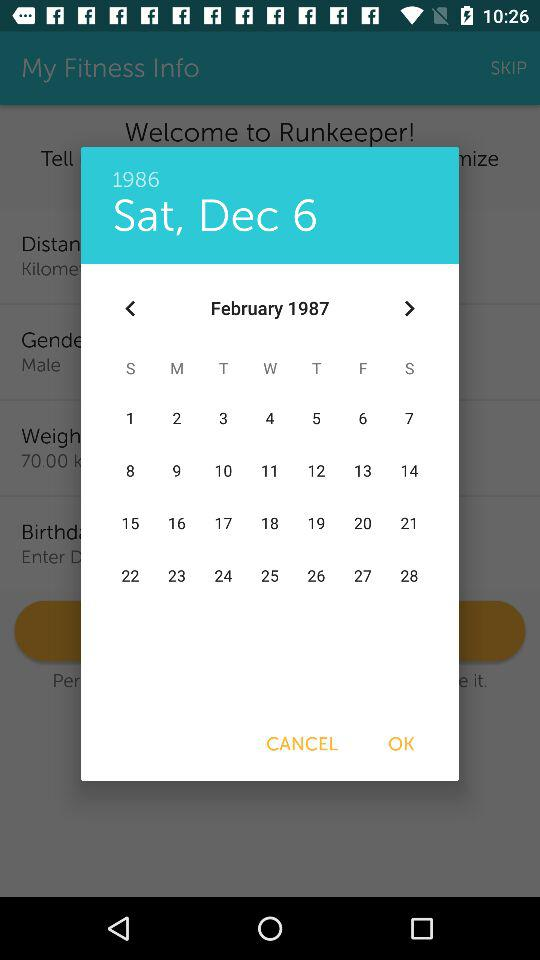What is the selected date? The selected date is Saturday, December 6, 1986. 